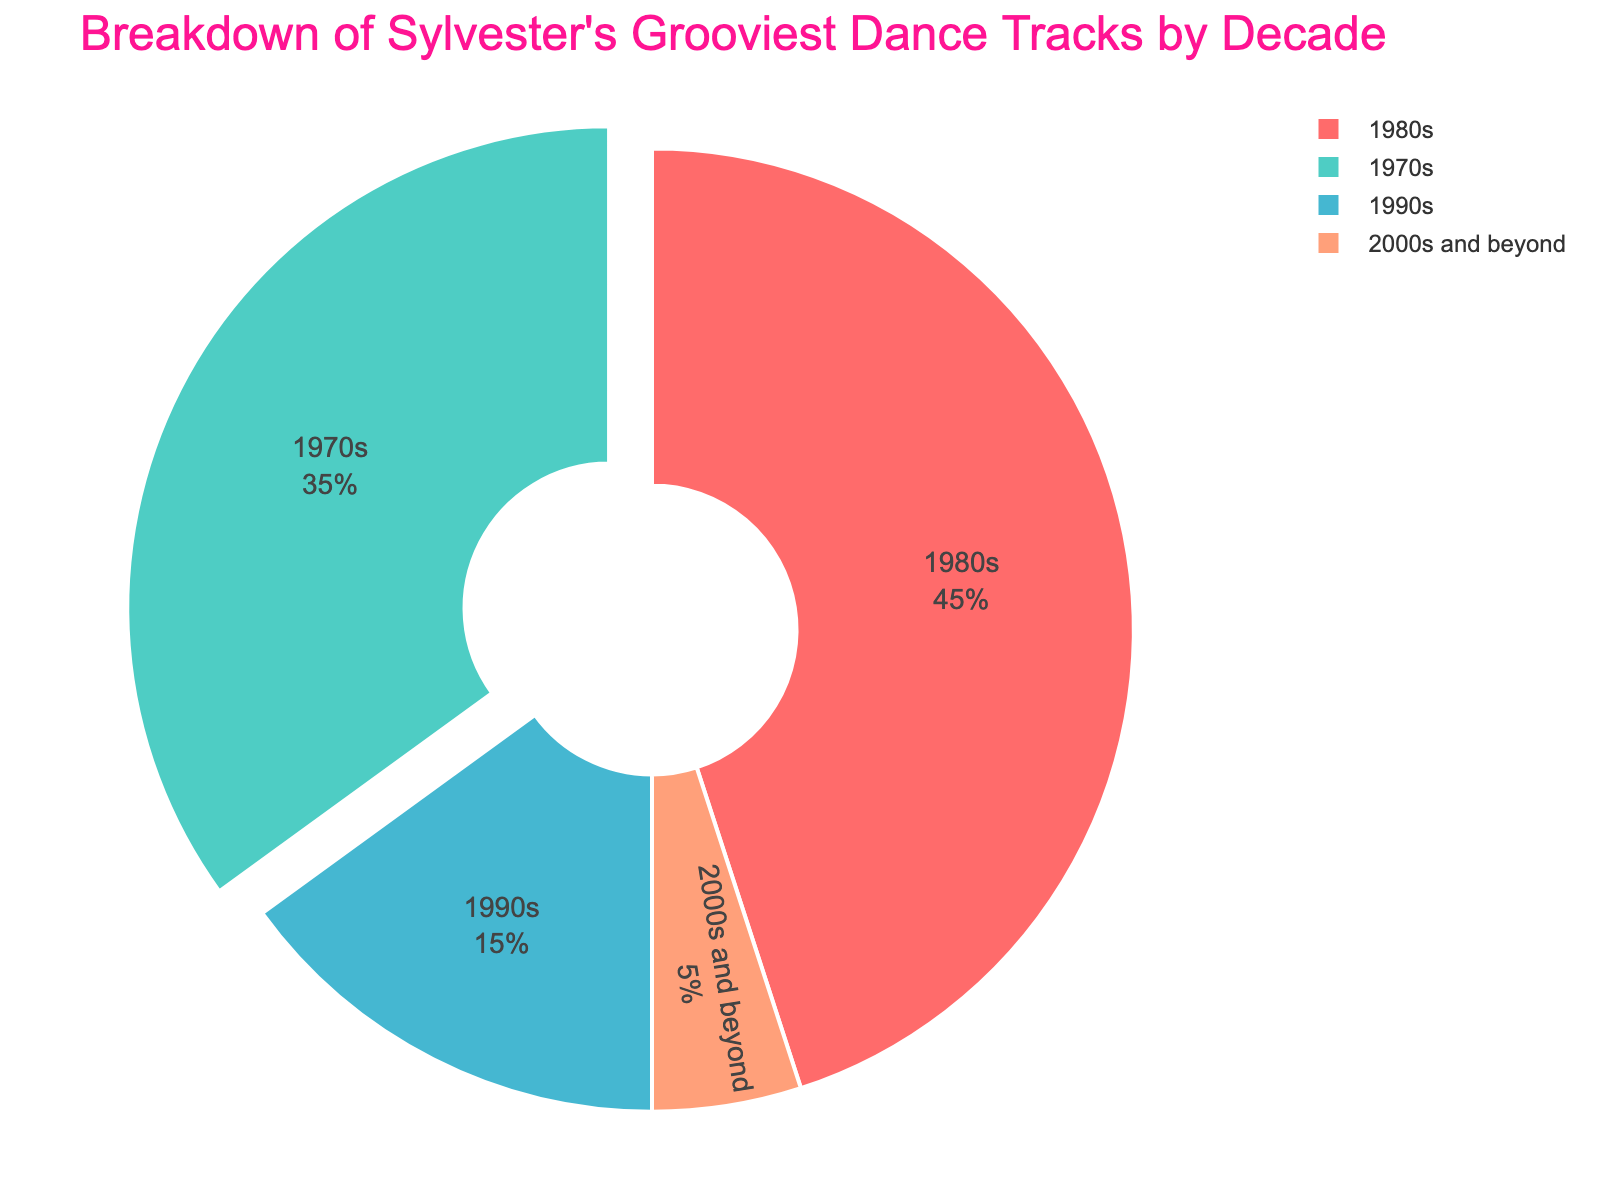What's the biggest chunk of Sylvester's dance tracks over the decades? The biggest chunk represents the 1980s with 45% of Sylvester's dance tracks, identified by the largest section of the pie chart.
Answer: 1980s What percentage of Sylvester's dance tracks are from the 1970s and 1980s combined? Sum the percentages of the 1970s (35%) and 1980s (45%): 35 + 45 = 80%.
Answer: 80% Which decade has the smallest share? The smallest share belongs to "2000s and beyond", represented by the smallest section of the pie chart at 5%.
Answer: 2000s and beyond How much larger is the 1980s section compared to the 1990s section? Subtract the percentage of the 1990s (15%) from the 1980s (45%): 45 - 15 = 30%.
Answer: 30% Is the percentage of dance tracks from the 1990s greater than that of the 2000s and beyond? The 1990s have 15%, and the 2000s and beyond have 5%. Since 15% is greater than 5%, the answer is yes.
Answer: Yes If you add the percentages of the 1980s and 1990s, do you get more than 50% of Sylvester's dance tracks? Sum the percentages of the 1980s (45%) and 1990s (15%): 45 + 15 = 60%, which is more than 50%.
Answer: Yes What is the visual color used for the 1970s section? The color used for the 1970s section is red, as indicated by the red segment in the pie chart.
Answer: Red Compare the contributions of the 1970s and 2000s and beyond. By how many points does the 1970s exceed the 2000s and beyond? Subtract the percentage of the 2000s and beyond (5%) from the 1970s (35%): 35 - 5 = 30%.
Answer: 30% What percentage of Sylvester's tracks is from before the 1990s? Add the percentages of the 1970s (35%) and 1980s (45%): 35 + 45 = 80%.
Answer: 80% Identify the decade with a sky-blue section in the pie chart. The sky-blue section represents the 1980s, as the 1980s segment is sky-blue.
Answer: 1980s 